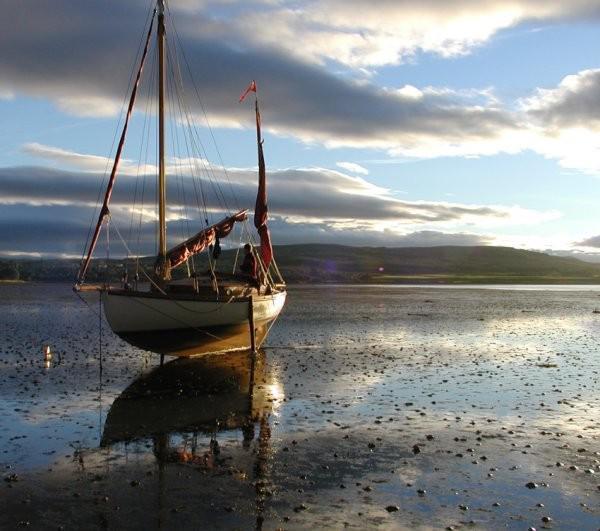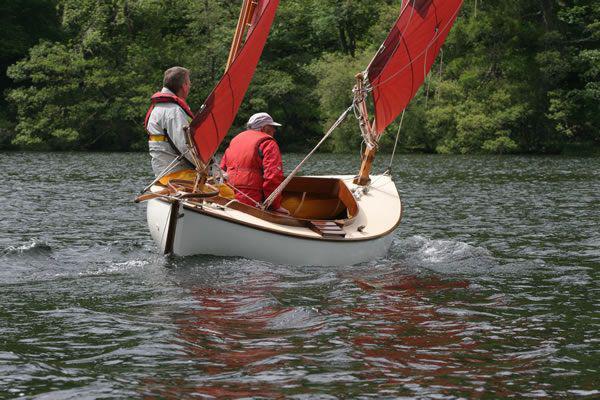The first image is the image on the left, the second image is the image on the right. Examine the images to the left and right. Is the description "The left and right image contains the same number of sailboats with a dark open sails." accurate? Answer yes or no. No. The first image is the image on the left, the second image is the image on the right. Considering the images on both sides, is "The sailboats in the left and right images each have unfurled sails that are colored instead of white." valid? Answer yes or no. No. 